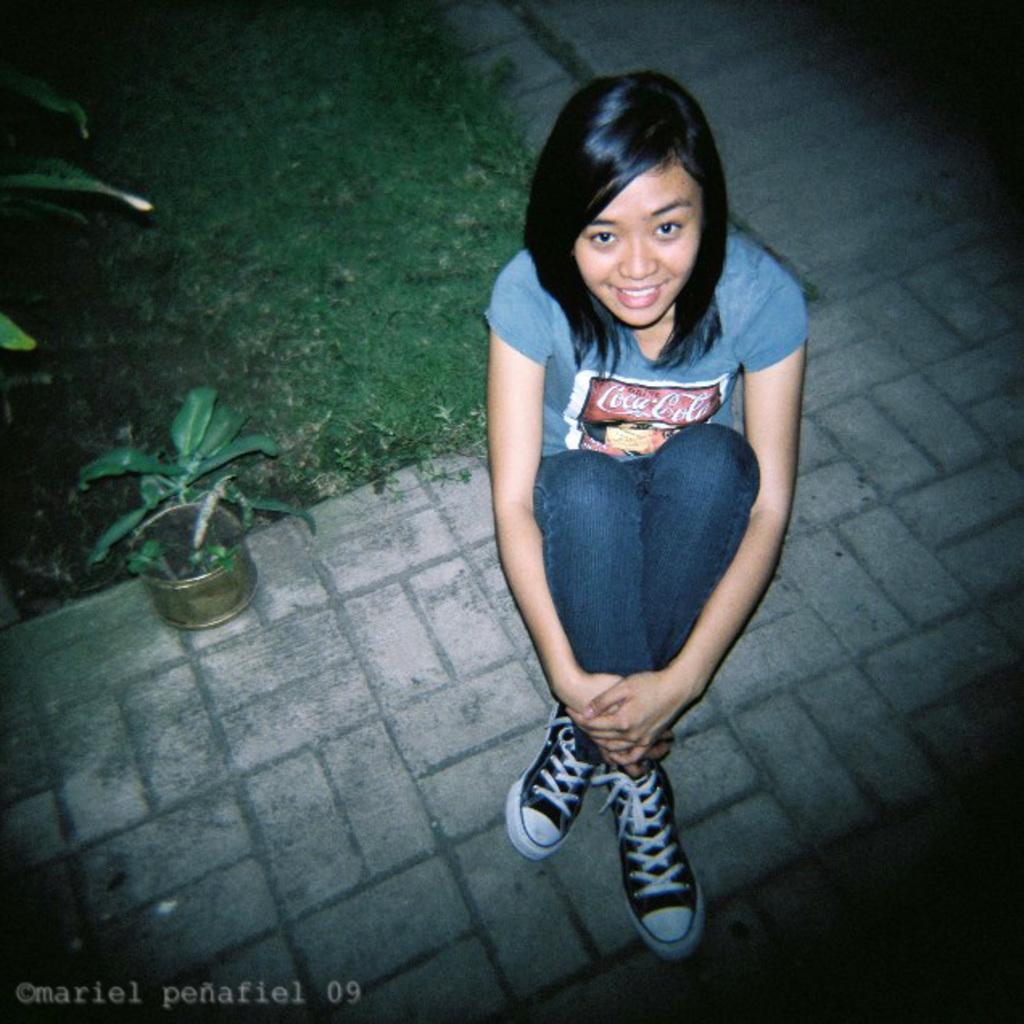How would you summarize this image in a sentence or two? In this picture we can see a woman sitting on the floor and in the background we can see a house plant,grass. 